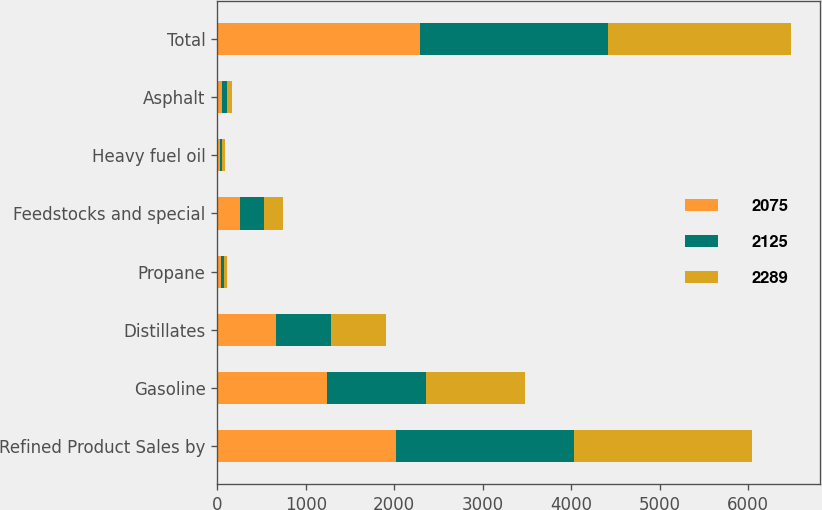<chart> <loc_0><loc_0><loc_500><loc_500><stacked_bar_chart><ecel><fcel>Refined Product Sales by<fcel>Gasoline<fcel>Distillates<fcel>Propane<fcel>Feedstocks and special<fcel>Heavy fuel oil<fcel>Asphalt<fcel>Total<nl><fcel>2075<fcel>2015<fcel>1241<fcel>667<fcel>36<fcel>258<fcel>30<fcel>57<fcel>2289<nl><fcel>2125<fcel>2014<fcel>1116<fcel>623<fcel>34<fcel>268<fcel>28<fcel>56<fcel>2125<nl><fcel>2289<fcel>2013<fcel>1126<fcel>615<fcel>37<fcel>214<fcel>29<fcel>54<fcel>2075<nl></chart> 